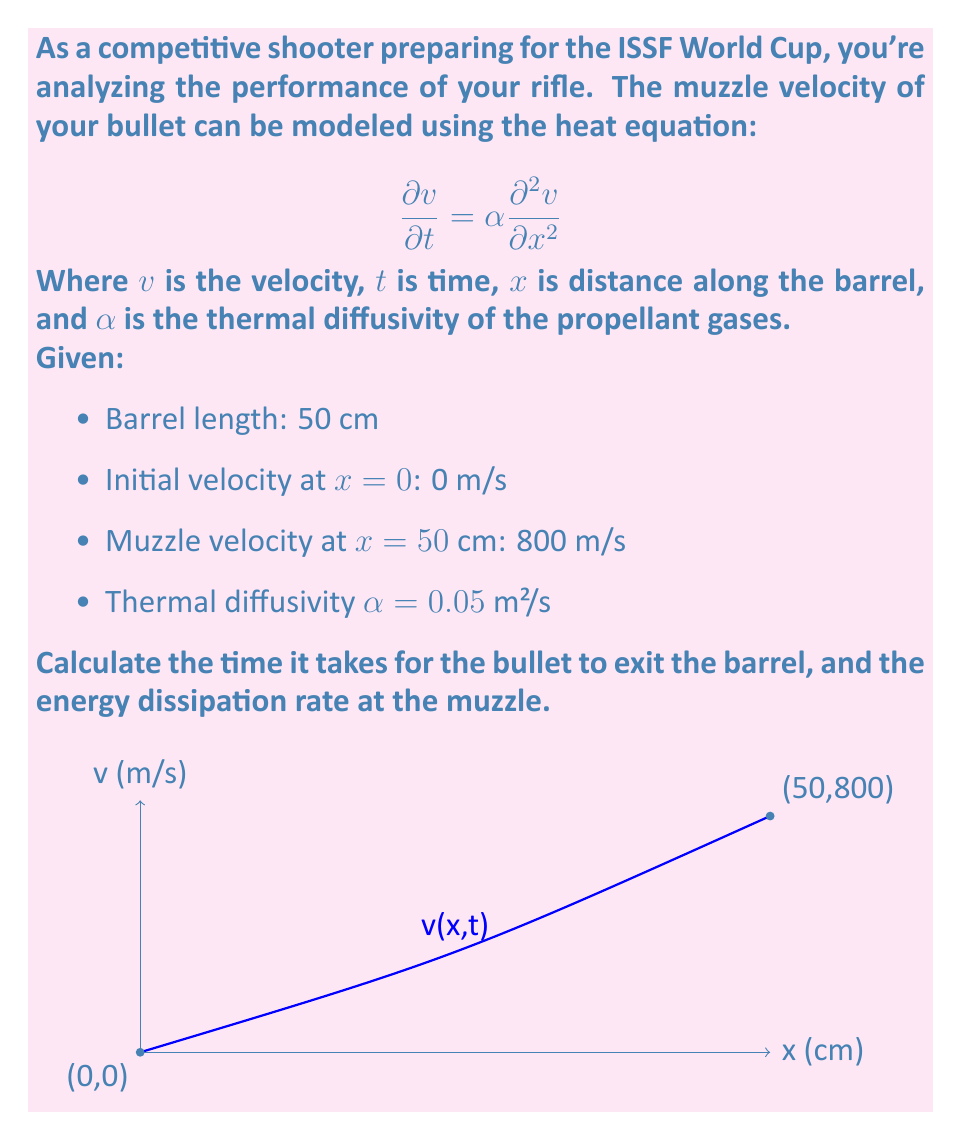Solve this math problem. Let's approach this step-by-step:

1) First, we need to find the time it takes for the bullet to exit the barrel. We can use the average velocity to calculate this:

   Average velocity = (Initial velocity + Muzzle velocity) / 2
   = (0 + 800) / 2 = 400 m/s

   Time = Distance / Average velocity
   = 0.50 m / 400 m/s = 0.00125 s

2) Now, for the energy dissipation rate, we need to use the heat equation. At the muzzle (x = L), we have:

   $$\frac{\partial v}{\partial t} = \alpha \frac{\partial^2 v}{\partial x^2}$$

3) We can approximate $\frac{\partial^2 v}{\partial x^2}$ at the muzzle using the finite difference method:

   $$\frac{\partial^2 v}{\partial x^2} \approx \frac{v(L-h) - 2v(L) + v(L+h)}{h^2}$$

   Where $h$ is a small distance. Let's use $h = 1$ cm = 0.01 m.

4) We know $v(L) = 800$ m/s, and we can assume $v(L+h) = 800$ m/s (velocity doesn't change after leaving the barrel). We need to estimate $v(L-h)$.

5) Using the average acceleration in the barrel:

   $a = (v_{final} - v_{initial}) / t = (800 - 0) / 0.00125 = 640,000$ m/s²

   $v(L-h) = v(L) - ah = 800 - 640,000 * 0.01 = 793.6$ m/s

6) Now we can calculate $\frac{\partial^2 v}{\partial x^2}$:

   $$\frac{\partial^2 v}{\partial x^2} \approx \frac{793.6 - 2(800) + 800}{0.01^2} = -128,000 \text{ m/s²/m}$$

7) Substituting this back into the heat equation:

   $$\frac{\partial v}{\partial t} = 0.05 * (-128,000) = -6,400 \text{ m/s²}$$

8) The energy dissipation rate is the rate of change of kinetic energy:

   $$\frac{d}{dt}(\frac{1}{2}mv^2) = mv\frac{dv}{dt}$$

   Assuming a typical bullet mass of 0.008 kg:

   Energy dissipation rate = $0.008 * 800 * (-6,400) = -40,960$ W
Answer: Time to exit barrel: 0.00125 s; Energy dissipation rate at muzzle: -40,960 W 